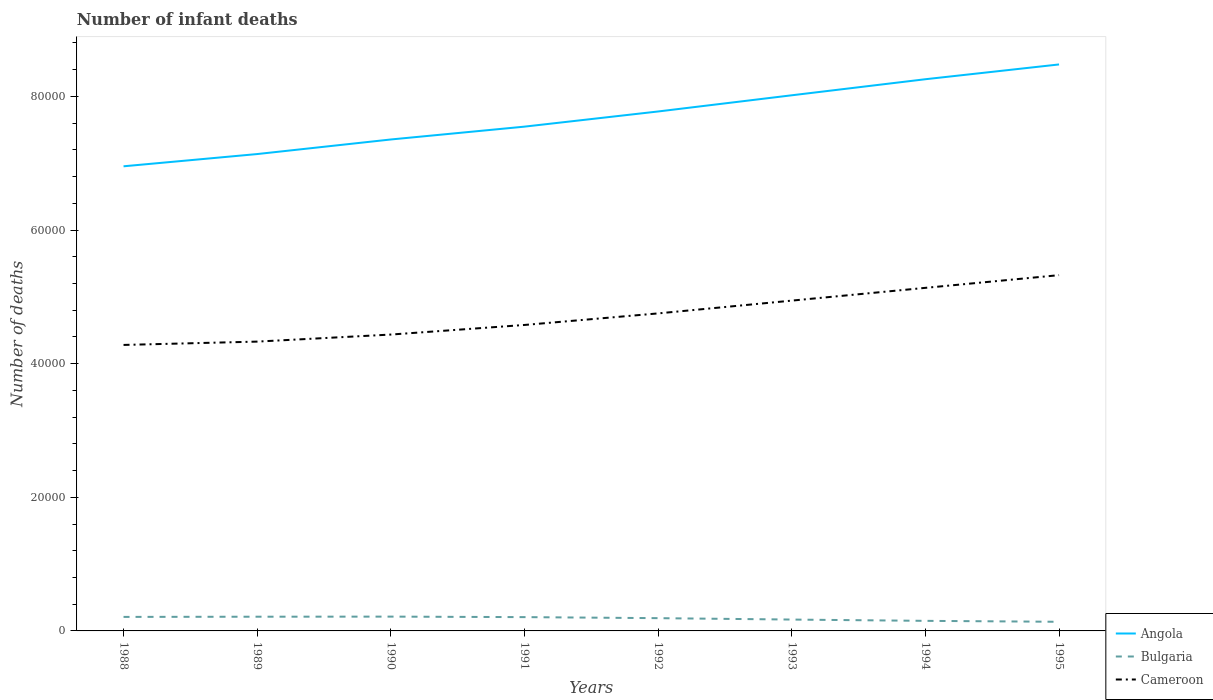Across all years, what is the maximum number of infant deaths in Bulgaria?
Offer a terse response. 1367. What is the total number of infant deaths in Bulgaria in the graph?
Ensure brevity in your answer.  427. What is the difference between the highest and the second highest number of infant deaths in Cameroon?
Make the answer very short. 1.04e+04. Is the number of infant deaths in Angola strictly greater than the number of infant deaths in Bulgaria over the years?
Your answer should be very brief. No. What is the difference between two consecutive major ticks on the Y-axis?
Provide a short and direct response. 2.00e+04. Are the values on the major ticks of Y-axis written in scientific E-notation?
Your answer should be compact. No. Where does the legend appear in the graph?
Your response must be concise. Bottom right. What is the title of the graph?
Give a very brief answer. Number of infant deaths. Does "Iran" appear as one of the legend labels in the graph?
Your response must be concise. No. What is the label or title of the X-axis?
Offer a very short reply. Years. What is the label or title of the Y-axis?
Your answer should be very brief. Number of deaths. What is the Number of deaths of Angola in 1988?
Your answer should be very brief. 6.95e+04. What is the Number of deaths of Bulgaria in 1988?
Make the answer very short. 2097. What is the Number of deaths in Cameroon in 1988?
Your answer should be very brief. 4.28e+04. What is the Number of deaths of Angola in 1989?
Offer a terse response. 7.14e+04. What is the Number of deaths of Bulgaria in 1989?
Your answer should be compact. 2127. What is the Number of deaths of Cameroon in 1989?
Provide a short and direct response. 4.33e+04. What is the Number of deaths in Angola in 1990?
Your response must be concise. 7.35e+04. What is the Number of deaths of Bulgaria in 1990?
Make the answer very short. 2141. What is the Number of deaths of Cameroon in 1990?
Offer a terse response. 4.44e+04. What is the Number of deaths in Angola in 1991?
Provide a short and direct response. 7.55e+04. What is the Number of deaths of Bulgaria in 1991?
Offer a very short reply. 2065. What is the Number of deaths in Cameroon in 1991?
Offer a terse response. 4.58e+04. What is the Number of deaths of Angola in 1992?
Your answer should be compact. 7.77e+04. What is the Number of deaths of Bulgaria in 1992?
Provide a succinct answer. 1910. What is the Number of deaths of Cameroon in 1992?
Offer a very short reply. 4.75e+04. What is the Number of deaths in Angola in 1993?
Your answer should be compact. 8.02e+04. What is the Number of deaths of Bulgaria in 1993?
Keep it short and to the point. 1700. What is the Number of deaths in Cameroon in 1993?
Your answer should be very brief. 4.94e+04. What is the Number of deaths of Angola in 1994?
Your answer should be compact. 8.26e+04. What is the Number of deaths in Bulgaria in 1994?
Provide a succinct answer. 1507. What is the Number of deaths in Cameroon in 1994?
Your response must be concise. 5.13e+04. What is the Number of deaths in Angola in 1995?
Your answer should be very brief. 8.48e+04. What is the Number of deaths of Bulgaria in 1995?
Make the answer very short. 1367. What is the Number of deaths of Cameroon in 1995?
Provide a short and direct response. 5.32e+04. Across all years, what is the maximum Number of deaths of Angola?
Ensure brevity in your answer.  8.48e+04. Across all years, what is the maximum Number of deaths in Bulgaria?
Provide a succinct answer. 2141. Across all years, what is the maximum Number of deaths of Cameroon?
Give a very brief answer. 5.32e+04. Across all years, what is the minimum Number of deaths in Angola?
Make the answer very short. 6.95e+04. Across all years, what is the minimum Number of deaths of Bulgaria?
Keep it short and to the point. 1367. Across all years, what is the minimum Number of deaths of Cameroon?
Provide a succinct answer. 4.28e+04. What is the total Number of deaths of Angola in the graph?
Provide a short and direct response. 6.15e+05. What is the total Number of deaths of Bulgaria in the graph?
Make the answer very short. 1.49e+04. What is the total Number of deaths of Cameroon in the graph?
Offer a very short reply. 3.78e+05. What is the difference between the Number of deaths of Angola in 1988 and that in 1989?
Offer a terse response. -1832. What is the difference between the Number of deaths of Cameroon in 1988 and that in 1989?
Your answer should be very brief. -498. What is the difference between the Number of deaths in Angola in 1988 and that in 1990?
Make the answer very short. -4014. What is the difference between the Number of deaths of Bulgaria in 1988 and that in 1990?
Provide a succinct answer. -44. What is the difference between the Number of deaths of Cameroon in 1988 and that in 1990?
Offer a terse response. -1553. What is the difference between the Number of deaths in Angola in 1988 and that in 1991?
Your answer should be compact. -5935. What is the difference between the Number of deaths of Bulgaria in 1988 and that in 1991?
Offer a terse response. 32. What is the difference between the Number of deaths in Cameroon in 1988 and that in 1991?
Your answer should be very brief. -2989. What is the difference between the Number of deaths of Angola in 1988 and that in 1992?
Make the answer very short. -8204. What is the difference between the Number of deaths in Bulgaria in 1988 and that in 1992?
Your response must be concise. 187. What is the difference between the Number of deaths of Cameroon in 1988 and that in 1992?
Your answer should be very brief. -4719. What is the difference between the Number of deaths of Angola in 1988 and that in 1993?
Your response must be concise. -1.06e+04. What is the difference between the Number of deaths in Bulgaria in 1988 and that in 1993?
Give a very brief answer. 397. What is the difference between the Number of deaths of Cameroon in 1988 and that in 1993?
Provide a succinct answer. -6631. What is the difference between the Number of deaths in Angola in 1988 and that in 1994?
Provide a short and direct response. -1.30e+04. What is the difference between the Number of deaths of Bulgaria in 1988 and that in 1994?
Your response must be concise. 590. What is the difference between the Number of deaths of Cameroon in 1988 and that in 1994?
Provide a short and direct response. -8543. What is the difference between the Number of deaths of Angola in 1988 and that in 1995?
Give a very brief answer. -1.52e+04. What is the difference between the Number of deaths in Bulgaria in 1988 and that in 1995?
Make the answer very short. 730. What is the difference between the Number of deaths in Cameroon in 1988 and that in 1995?
Your response must be concise. -1.04e+04. What is the difference between the Number of deaths in Angola in 1989 and that in 1990?
Offer a very short reply. -2182. What is the difference between the Number of deaths in Bulgaria in 1989 and that in 1990?
Make the answer very short. -14. What is the difference between the Number of deaths of Cameroon in 1989 and that in 1990?
Provide a short and direct response. -1055. What is the difference between the Number of deaths in Angola in 1989 and that in 1991?
Keep it short and to the point. -4103. What is the difference between the Number of deaths of Bulgaria in 1989 and that in 1991?
Give a very brief answer. 62. What is the difference between the Number of deaths of Cameroon in 1989 and that in 1991?
Keep it short and to the point. -2491. What is the difference between the Number of deaths in Angola in 1989 and that in 1992?
Your answer should be very brief. -6372. What is the difference between the Number of deaths in Bulgaria in 1989 and that in 1992?
Offer a terse response. 217. What is the difference between the Number of deaths in Cameroon in 1989 and that in 1992?
Provide a succinct answer. -4221. What is the difference between the Number of deaths in Angola in 1989 and that in 1993?
Your answer should be very brief. -8794. What is the difference between the Number of deaths in Bulgaria in 1989 and that in 1993?
Give a very brief answer. 427. What is the difference between the Number of deaths of Cameroon in 1989 and that in 1993?
Provide a short and direct response. -6133. What is the difference between the Number of deaths in Angola in 1989 and that in 1994?
Your response must be concise. -1.12e+04. What is the difference between the Number of deaths of Bulgaria in 1989 and that in 1994?
Provide a succinct answer. 620. What is the difference between the Number of deaths in Cameroon in 1989 and that in 1994?
Offer a terse response. -8045. What is the difference between the Number of deaths of Angola in 1989 and that in 1995?
Give a very brief answer. -1.34e+04. What is the difference between the Number of deaths of Bulgaria in 1989 and that in 1995?
Keep it short and to the point. 760. What is the difference between the Number of deaths of Cameroon in 1989 and that in 1995?
Ensure brevity in your answer.  -9946. What is the difference between the Number of deaths in Angola in 1990 and that in 1991?
Make the answer very short. -1921. What is the difference between the Number of deaths in Cameroon in 1990 and that in 1991?
Provide a succinct answer. -1436. What is the difference between the Number of deaths of Angola in 1990 and that in 1992?
Give a very brief answer. -4190. What is the difference between the Number of deaths of Bulgaria in 1990 and that in 1992?
Keep it short and to the point. 231. What is the difference between the Number of deaths in Cameroon in 1990 and that in 1992?
Provide a short and direct response. -3166. What is the difference between the Number of deaths of Angola in 1990 and that in 1993?
Offer a very short reply. -6612. What is the difference between the Number of deaths in Bulgaria in 1990 and that in 1993?
Give a very brief answer. 441. What is the difference between the Number of deaths in Cameroon in 1990 and that in 1993?
Give a very brief answer. -5078. What is the difference between the Number of deaths of Angola in 1990 and that in 1994?
Give a very brief answer. -9017. What is the difference between the Number of deaths of Bulgaria in 1990 and that in 1994?
Offer a very short reply. 634. What is the difference between the Number of deaths of Cameroon in 1990 and that in 1994?
Your response must be concise. -6990. What is the difference between the Number of deaths in Angola in 1990 and that in 1995?
Provide a succinct answer. -1.12e+04. What is the difference between the Number of deaths of Bulgaria in 1990 and that in 1995?
Ensure brevity in your answer.  774. What is the difference between the Number of deaths in Cameroon in 1990 and that in 1995?
Provide a succinct answer. -8891. What is the difference between the Number of deaths in Angola in 1991 and that in 1992?
Provide a short and direct response. -2269. What is the difference between the Number of deaths in Bulgaria in 1991 and that in 1992?
Your answer should be very brief. 155. What is the difference between the Number of deaths in Cameroon in 1991 and that in 1992?
Ensure brevity in your answer.  -1730. What is the difference between the Number of deaths in Angola in 1991 and that in 1993?
Your response must be concise. -4691. What is the difference between the Number of deaths of Bulgaria in 1991 and that in 1993?
Provide a succinct answer. 365. What is the difference between the Number of deaths of Cameroon in 1991 and that in 1993?
Ensure brevity in your answer.  -3642. What is the difference between the Number of deaths of Angola in 1991 and that in 1994?
Keep it short and to the point. -7096. What is the difference between the Number of deaths of Bulgaria in 1991 and that in 1994?
Make the answer very short. 558. What is the difference between the Number of deaths of Cameroon in 1991 and that in 1994?
Make the answer very short. -5554. What is the difference between the Number of deaths in Angola in 1991 and that in 1995?
Provide a succinct answer. -9308. What is the difference between the Number of deaths of Bulgaria in 1991 and that in 1995?
Your answer should be very brief. 698. What is the difference between the Number of deaths of Cameroon in 1991 and that in 1995?
Your response must be concise. -7455. What is the difference between the Number of deaths in Angola in 1992 and that in 1993?
Keep it short and to the point. -2422. What is the difference between the Number of deaths in Bulgaria in 1992 and that in 1993?
Your response must be concise. 210. What is the difference between the Number of deaths of Cameroon in 1992 and that in 1993?
Make the answer very short. -1912. What is the difference between the Number of deaths in Angola in 1992 and that in 1994?
Make the answer very short. -4827. What is the difference between the Number of deaths of Bulgaria in 1992 and that in 1994?
Make the answer very short. 403. What is the difference between the Number of deaths in Cameroon in 1992 and that in 1994?
Offer a terse response. -3824. What is the difference between the Number of deaths in Angola in 1992 and that in 1995?
Give a very brief answer. -7039. What is the difference between the Number of deaths of Bulgaria in 1992 and that in 1995?
Offer a terse response. 543. What is the difference between the Number of deaths in Cameroon in 1992 and that in 1995?
Keep it short and to the point. -5725. What is the difference between the Number of deaths in Angola in 1993 and that in 1994?
Offer a very short reply. -2405. What is the difference between the Number of deaths of Bulgaria in 1993 and that in 1994?
Provide a succinct answer. 193. What is the difference between the Number of deaths in Cameroon in 1993 and that in 1994?
Offer a very short reply. -1912. What is the difference between the Number of deaths in Angola in 1993 and that in 1995?
Make the answer very short. -4617. What is the difference between the Number of deaths of Bulgaria in 1993 and that in 1995?
Offer a very short reply. 333. What is the difference between the Number of deaths of Cameroon in 1993 and that in 1995?
Keep it short and to the point. -3813. What is the difference between the Number of deaths of Angola in 1994 and that in 1995?
Keep it short and to the point. -2212. What is the difference between the Number of deaths of Bulgaria in 1994 and that in 1995?
Keep it short and to the point. 140. What is the difference between the Number of deaths of Cameroon in 1994 and that in 1995?
Provide a succinct answer. -1901. What is the difference between the Number of deaths of Angola in 1988 and the Number of deaths of Bulgaria in 1989?
Your answer should be very brief. 6.74e+04. What is the difference between the Number of deaths of Angola in 1988 and the Number of deaths of Cameroon in 1989?
Give a very brief answer. 2.62e+04. What is the difference between the Number of deaths of Bulgaria in 1988 and the Number of deaths of Cameroon in 1989?
Keep it short and to the point. -4.12e+04. What is the difference between the Number of deaths in Angola in 1988 and the Number of deaths in Bulgaria in 1990?
Your answer should be very brief. 6.74e+04. What is the difference between the Number of deaths of Angola in 1988 and the Number of deaths of Cameroon in 1990?
Provide a succinct answer. 2.52e+04. What is the difference between the Number of deaths of Bulgaria in 1988 and the Number of deaths of Cameroon in 1990?
Your answer should be very brief. -4.23e+04. What is the difference between the Number of deaths of Angola in 1988 and the Number of deaths of Bulgaria in 1991?
Provide a short and direct response. 6.75e+04. What is the difference between the Number of deaths in Angola in 1988 and the Number of deaths in Cameroon in 1991?
Your answer should be compact. 2.37e+04. What is the difference between the Number of deaths of Bulgaria in 1988 and the Number of deaths of Cameroon in 1991?
Offer a very short reply. -4.37e+04. What is the difference between the Number of deaths in Angola in 1988 and the Number of deaths in Bulgaria in 1992?
Provide a succinct answer. 6.76e+04. What is the difference between the Number of deaths in Angola in 1988 and the Number of deaths in Cameroon in 1992?
Your response must be concise. 2.20e+04. What is the difference between the Number of deaths in Bulgaria in 1988 and the Number of deaths in Cameroon in 1992?
Ensure brevity in your answer.  -4.54e+04. What is the difference between the Number of deaths in Angola in 1988 and the Number of deaths in Bulgaria in 1993?
Your response must be concise. 6.78e+04. What is the difference between the Number of deaths of Angola in 1988 and the Number of deaths of Cameroon in 1993?
Your answer should be very brief. 2.01e+04. What is the difference between the Number of deaths of Bulgaria in 1988 and the Number of deaths of Cameroon in 1993?
Provide a succinct answer. -4.73e+04. What is the difference between the Number of deaths in Angola in 1988 and the Number of deaths in Bulgaria in 1994?
Give a very brief answer. 6.80e+04. What is the difference between the Number of deaths of Angola in 1988 and the Number of deaths of Cameroon in 1994?
Provide a short and direct response. 1.82e+04. What is the difference between the Number of deaths in Bulgaria in 1988 and the Number of deaths in Cameroon in 1994?
Give a very brief answer. -4.92e+04. What is the difference between the Number of deaths of Angola in 1988 and the Number of deaths of Bulgaria in 1995?
Your answer should be very brief. 6.82e+04. What is the difference between the Number of deaths in Angola in 1988 and the Number of deaths in Cameroon in 1995?
Provide a succinct answer. 1.63e+04. What is the difference between the Number of deaths in Bulgaria in 1988 and the Number of deaths in Cameroon in 1995?
Provide a succinct answer. -5.11e+04. What is the difference between the Number of deaths of Angola in 1989 and the Number of deaths of Bulgaria in 1990?
Provide a succinct answer. 6.92e+04. What is the difference between the Number of deaths in Angola in 1989 and the Number of deaths in Cameroon in 1990?
Keep it short and to the point. 2.70e+04. What is the difference between the Number of deaths of Bulgaria in 1989 and the Number of deaths of Cameroon in 1990?
Ensure brevity in your answer.  -4.22e+04. What is the difference between the Number of deaths of Angola in 1989 and the Number of deaths of Bulgaria in 1991?
Your answer should be compact. 6.93e+04. What is the difference between the Number of deaths of Angola in 1989 and the Number of deaths of Cameroon in 1991?
Your answer should be very brief. 2.56e+04. What is the difference between the Number of deaths of Bulgaria in 1989 and the Number of deaths of Cameroon in 1991?
Make the answer very short. -4.37e+04. What is the difference between the Number of deaths in Angola in 1989 and the Number of deaths in Bulgaria in 1992?
Offer a very short reply. 6.95e+04. What is the difference between the Number of deaths in Angola in 1989 and the Number of deaths in Cameroon in 1992?
Your answer should be very brief. 2.38e+04. What is the difference between the Number of deaths in Bulgaria in 1989 and the Number of deaths in Cameroon in 1992?
Ensure brevity in your answer.  -4.54e+04. What is the difference between the Number of deaths in Angola in 1989 and the Number of deaths in Bulgaria in 1993?
Provide a succinct answer. 6.97e+04. What is the difference between the Number of deaths in Angola in 1989 and the Number of deaths in Cameroon in 1993?
Ensure brevity in your answer.  2.19e+04. What is the difference between the Number of deaths of Bulgaria in 1989 and the Number of deaths of Cameroon in 1993?
Offer a very short reply. -4.73e+04. What is the difference between the Number of deaths in Angola in 1989 and the Number of deaths in Bulgaria in 1994?
Your answer should be very brief. 6.99e+04. What is the difference between the Number of deaths in Angola in 1989 and the Number of deaths in Cameroon in 1994?
Keep it short and to the point. 2.00e+04. What is the difference between the Number of deaths in Bulgaria in 1989 and the Number of deaths in Cameroon in 1994?
Provide a succinct answer. -4.92e+04. What is the difference between the Number of deaths in Angola in 1989 and the Number of deaths in Bulgaria in 1995?
Offer a terse response. 7.00e+04. What is the difference between the Number of deaths of Angola in 1989 and the Number of deaths of Cameroon in 1995?
Offer a very short reply. 1.81e+04. What is the difference between the Number of deaths in Bulgaria in 1989 and the Number of deaths in Cameroon in 1995?
Offer a very short reply. -5.11e+04. What is the difference between the Number of deaths in Angola in 1990 and the Number of deaths in Bulgaria in 1991?
Provide a short and direct response. 7.15e+04. What is the difference between the Number of deaths in Angola in 1990 and the Number of deaths in Cameroon in 1991?
Provide a short and direct response. 2.78e+04. What is the difference between the Number of deaths in Bulgaria in 1990 and the Number of deaths in Cameroon in 1991?
Provide a succinct answer. -4.36e+04. What is the difference between the Number of deaths in Angola in 1990 and the Number of deaths in Bulgaria in 1992?
Provide a succinct answer. 7.16e+04. What is the difference between the Number of deaths of Angola in 1990 and the Number of deaths of Cameroon in 1992?
Your response must be concise. 2.60e+04. What is the difference between the Number of deaths of Bulgaria in 1990 and the Number of deaths of Cameroon in 1992?
Your answer should be compact. -4.54e+04. What is the difference between the Number of deaths of Angola in 1990 and the Number of deaths of Bulgaria in 1993?
Ensure brevity in your answer.  7.18e+04. What is the difference between the Number of deaths of Angola in 1990 and the Number of deaths of Cameroon in 1993?
Your answer should be compact. 2.41e+04. What is the difference between the Number of deaths in Bulgaria in 1990 and the Number of deaths in Cameroon in 1993?
Make the answer very short. -4.73e+04. What is the difference between the Number of deaths in Angola in 1990 and the Number of deaths in Bulgaria in 1994?
Your answer should be very brief. 7.20e+04. What is the difference between the Number of deaths of Angola in 1990 and the Number of deaths of Cameroon in 1994?
Provide a short and direct response. 2.22e+04. What is the difference between the Number of deaths of Bulgaria in 1990 and the Number of deaths of Cameroon in 1994?
Your response must be concise. -4.92e+04. What is the difference between the Number of deaths in Angola in 1990 and the Number of deaths in Bulgaria in 1995?
Offer a very short reply. 7.22e+04. What is the difference between the Number of deaths in Angola in 1990 and the Number of deaths in Cameroon in 1995?
Provide a succinct answer. 2.03e+04. What is the difference between the Number of deaths of Bulgaria in 1990 and the Number of deaths of Cameroon in 1995?
Your answer should be very brief. -5.11e+04. What is the difference between the Number of deaths of Angola in 1991 and the Number of deaths of Bulgaria in 1992?
Your response must be concise. 7.36e+04. What is the difference between the Number of deaths of Angola in 1991 and the Number of deaths of Cameroon in 1992?
Make the answer very short. 2.80e+04. What is the difference between the Number of deaths of Bulgaria in 1991 and the Number of deaths of Cameroon in 1992?
Provide a short and direct response. -4.55e+04. What is the difference between the Number of deaths of Angola in 1991 and the Number of deaths of Bulgaria in 1993?
Provide a succinct answer. 7.38e+04. What is the difference between the Number of deaths of Angola in 1991 and the Number of deaths of Cameroon in 1993?
Make the answer very short. 2.60e+04. What is the difference between the Number of deaths of Bulgaria in 1991 and the Number of deaths of Cameroon in 1993?
Your answer should be very brief. -4.74e+04. What is the difference between the Number of deaths of Angola in 1991 and the Number of deaths of Bulgaria in 1994?
Offer a terse response. 7.40e+04. What is the difference between the Number of deaths of Angola in 1991 and the Number of deaths of Cameroon in 1994?
Offer a very short reply. 2.41e+04. What is the difference between the Number of deaths in Bulgaria in 1991 and the Number of deaths in Cameroon in 1994?
Ensure brevity in your answer.  -4.93e+04. What is the difference between the Number of deaths of Angola in 1991 and the Number of deaths of Bulgaria in 1995?
Your answer should be very brief. 7.41e+04. What is the difference between the Number of deaths of Angola in 1991 and the Number of deaths of Cameroon in 1995?
Provide a succinct answer. 2.22e+04. What is the difference between the Number of deaths of Bulgaria in 1991 and the Number of deaths of Cameroon in 1995?
Give a very brief answer. -5.12e+04. What is the difference between the Number of deaths in Angola in 1992 and the Number of deaths in Bulgaria in 1993?
Your answer should be compact. 7.60e+04. What is the difference between the Number of deaths of Angola in 1992 and the Number of deaths of Cameroon in 1993?
Your response must be concise. 2.83e+04. What is the difference between the Number of deaths in Bulgaria in 1992 and the Number of deaths in Cameroon in 1993?
Make the answer very short. -4.75e+04. What is the difference between the Number of deaths in Angola in 1992 and the Number of deaths in Bulgaria in 1994?
Your response must be concise. 7.62e+04. What is the difference between the Number of deaths in Angola in 1992 and the Number of deaths in Cameroon in 1994?
Offer a terse response. 2.64e+04. What is the difference between the Number of deaths in Bulgaria in 1992 and the Number of deaths in Cameroon in 1994?
Ensure brevity in your answer.  -4.94e+04. What is the difference between the Number of deaths in Angola in 1992 and the Number of deaths in Bulgaria in 1995?
Keep it short and to the point. 7.64e+04. What is the difference between the Number of deaths in Angola in 1992 and the Number of deaths in Cameroon in 1995?
Provide a short and direct response. 2.45e+04. What is the difference between the Number of deaths in Bulgaria in 1992 and the Number of deaths in Cameroon in 1995?
Your response must be concise. -5.13e+04. What is the difference between the Number of deaths of Angola in 1993 and the Number of deaths of Bulgaria in 1994?
Offer a very short reply. 7.87e+04. What is the difference between the Number of deaths in Angola in 1993 and the Number of deaths in Cameroon in 1994?
Ensure brevity in your answer.  2.88e+04. What is the difference between the Number of deaths of Bulgaria in 1993 and the Number of deaths of Cameroon in 1994?
Provide a succinct answer. -4.96e+04. What is the difference between the Number of deaths of Angola in 1993 and the Number of deaths of Bulgaria in 1995?
Provide a succinct answer. 7.88e+04. What is the difference between the Number of deaths in Angola in 1993 and the Number of deaths in Cameroon in 1995?
Keep it short and to the point. 2.69e+04. What is the difference between the Number of deaths of Bulgaria in 1993 and the Number of deaths of Cameroon in 1995?
Provide a succinct answer. -5.15e+04. What is the difference between the Number of deaths in Angola in 1994 and the Number of deaths in Bulgaria in 1995?
Your response must be concise. 8.12e+04. What is the difference between the Number of deaths of Angola in 1994 and the Number of deaths of Cameroon in 1995?
Provide a succinct answer. 2.93e+04. What is the difference between the Number of deaths in Bulgaria in 1994 and the Number of deaths in Cameroon in 1995?
Keep it short and to the point. -5.17e+04. What is the average Number of deaths of Angola per year?
Provide a succinct answer. 7.69e+04. What is the average Number of deaths in Bulgaria per year?
Give a very brief answer. 1864.25. What is the average Number of deaths in Cameroon per year?
Make the answer very short. 4.72e+04. In the year 1988, what is the difference between the Number of deaths in Angola and Number of deaths in Bulgaria?
Make the answer very short. 6.74e+04. In the year 1988, what is the difference between the Number of deaths of Angola and Number of deaths of Cameroon?
Make the answer very short. 2.67e+04. In the year 1988, what is the difference between the Number of deaths of Bulgaria and Number of deaths of Cameroon?
Provide a short and direct response. -4.07e+04. In the year 1989, what is the difference between the Number of deaths of Angola and Number of deaths of Bulgaria?
Ensure brevity in your answer.  6.92e+04. In the year 1989, what is the difference between the Number of deaths in Angola and Number of deaths in Cameroon?
Your response must be concise. 2.81e+04. In the year 1989, what is the difference between the Number of deaths of Bulgaria and Number of deaths of Cameroon?
Your response must be concise. -4.12e+04. In the year 1990, what is the difference between the Number of deaths of Angola and Number of deaths of Bulgaria?
Your answer should be very brief. 7.14e+04. In the year 1990, what is the difference between the Number of deaths of Angola and Number of deaths of Cameroon?
Your answer should be very brief. 2.92e+04. In the year 1990, what is the difference between the Number of deaths of Bulgaria and Number of deaths of Cameroon?
Offer a very short reply. -4.22e+04. In the year 1991, what is the difference between the Number of deaths in Angola and Number of deaths in Bulgaria?
Offer a terse response. 7.34e+04. In the year 1991, what is the difference between the Number of deaths of Angola and Number of deaths of Cameroon?
Offer a terse response. 2.97e+04. In the year 1991, what is the difference between the Number of deaths of Bulgaria and Number of deaths of Cameroon?
Ensure brevity in your answer.  -4.37e+04. In the year 1992, what is the difference between the Number of deaths of Angola and Number of deaths of Bulgaria?
Your answer should be very brief. 7.58e+04. In the year 1992, what is the difference between the Number of deaths in Angola and Number of deaths in Cameroon?
Keep it short and to the point. 3.02e+04. In the year 1992, what is the difference between the Number of deaths in Bulgaria and Number of deaths in Cameroon?
Provide a succinct answer. -4.56e+04. In the year 1993, what is the difference between the Number of deaths of Angola and Number of deaths of Bulgaria?
Your answer should be compact. 7.85e+04. In the year 1993, what is the difference between the Number of deaths of Angola and Number of deaths of Cameroon?
Your response must be concise. 3.07e+04. In the year 1993, what is the difference between the Number of deaths of Bulgaria and Number of deaths of Cameroon?
Your answer should be very brief. -4.77e+04. In the year 1994, what is the difference between the Number of deaths in Angola and Number of deaths in Bulgaria?
Give a very brief answer. 8.11e+04. In the year 1994, what is the difference between the Number of deaths of Angola and Number of deaths of Cameroon?
Your answer should be compact. 3.12e+04. In the year 1994, what is the difference between the Number of deaths in Bulgaria and Number of deaths in Cameroon?
Keep it short and to the point. -4.98e+04. In the year 1995, what is the difference between the Number of deaths in Angola and Number of deaths in Bulgaria?
Give a very brief answer. 8.34e+04. In the year 1995, what is the difference between the Number of deaths of Angola and Number of deaths of Cameroon?
Ensure brevity in your answer.  3.15e+04. In the year 1995, what is the difference between the Number of deaths in Bulgaria and Number of deaths in Cameroon?
Your response must be concise. -5.19e+04. What is the ratio of the Number of deaths in Angola in 1988 to that in 1989?
Make the answer very short. 0.97. What is the ratio of the Number of deaths in Bulgaria in 1988 to that in 1989?
Offer a very short reply. 0.99. What is the ratio of the Number of deaths in Cameroon in 1988 to that in 1989?
Offer a terse response. 0.99. What is the ratio of the Number of deaths in Angola in 1988 to that in 1990?
Your answer should be compact. 0.95. What is the ratio of the Number of deaths in Bulgaria in 1988 to that in 1990?
Your response must be concise. 0.98. What is the ratio of the Number of deaths of Angola in 1988 to that in 1991?
Your response must be concise. 0.92. What is the ratio of the Number of deaths in Bulgaria in 1988 to that in 1991?
Your answer should be very brief. 1.02. What is the ratio of the Number of deaths of Cameroon in 1988 to that in 1991?
Offer a very short reply. 0.93. What is the ratio of the Number of deaths of Angola in 1988 to that in 1992?
Your response must be concise. 0.89. What is the ratio of the Number of deaths of Bulgaria in 1988 to that in 1992?
Your answer should be very brief. 1.1. What is the ratio of the Number of deaths of Cameroon in 1988 to that in 1992?
Offer a terse response. 0.9. What is the ratio of the Number of deaths of Angola in 1988 to that in 1993?
Make the answer very short. 0.87. What is the ratio of the Number of deaths of Bulgaria in 1988 to that in 1993?
Ensure brevity in your answer.  1.23. What is the ratio of the Number of deaths in Cameroon in 1988 to that in 1993?
Make the answer very short. 0.87. What is the ratio of the Number of deaths in Angola in 1988 to that in 1994?
Offer a very short reply. 0.84. What is the ratio of the Number of deaths of Bulgaria in 1988 to that in 1994?
Give a very brief answer. 1.39. What is the ratio of the Number of deaths of Cameroon in 1988 to that in 1994?
Ensure brevity in your answer.  0.83. What is the ratio of the Number of deaths in Angola in 1988 to that in 1995?
Keep it short and to the point. 0.82. What is the ratio of the Number of deaths of Bulgaria in 1988 to that in 1995?
Your answer should be compact. 1.53. What is the ratio of the Number of deaths of Cameroon in 1988 to that in 1995?
Make the answer very short. 0.8. What is the ratio of the Number of deaths in Angola in 1989 to that in 1990?
Ensure brevity in your answer.  0.97. What is the ratio of the Number of deaths in Cameroon in 1989 to that in 1990?
Ensure brevity in your answer.  0.98. What is the ratio of the Number of deaths in Angola in 1989 to that in 1991?
Provide a short and direct response. 0.95. What is the ratio of the Number of deaths of Cameroon in 1989 to that in 1991?
Make the answer very short. 0.95. What is the ratio of the Number of deaths in Angola in 1989 to that in 1992?
Offer a very short reply. 0.92. What is the ratio of the Number of deaths in Bulgaria in 1989 to that in 1992?
Keep it short and to the point. 1.11. What is the ratio of the Number of deaths of Cameroon in 1989 to that in 1992?
Give a very brief answer. 0.91. What is the ratio of the Number of deaths of Angola in 1989 to that in 1993?
Keep it short and to the point. 0.89. What is the ratio of the Number of deaths in Bulgaria in 1989 to that in 1993?
Provide a succinct answer. 1.25. What is the ratio of the Number of deaths of Cameroon in 1989 to that in 1993?
Your response must be concise. 0.88. What is the ratio of the Number of deaths of Angola in 1989 to that in 1994?
Offer a terse response. 0.86. What is the ratio of the Number of deaths of Bulgaria in 1989 to that in 1994?
Offer a very short reply. 1.41. What is the ratio of the Number of deaths of Cameroon in 1989 to that in 1994?
Offer a terse response. 0.84. What is the ratio of the Number of deaths in Angola in 1989 to that in 1995?
Your response must be concise. 0.84. What is the ratio of the Number of deaths in Bulgaria in 1989 to that in 1995?
Offer a terse response. 1.56. What is the ratio of the Number of deaths of Cameroon in 1989 to that in 1995?
Provide a succinct answer. 0.81. What is the ratio of the Number of deaths in Angola in 1990 to that in 1991?
Provide a short and direct response. 0.97. What is the ratio of the Number of deaths of Bulgaria in 1990 to that in 1991?
Offer a very short reply. 1.04. What is the ratio of the Number of deaths of Cameroon in 1990 to that in 1991?
Provide a short and direct response. 0.97. What is the ratio of the Number of deaths in Angola in 1990 to that in 1992?
Make the answer very short. 0.95. What is the ratio of the Number of deaths of Bulgaria in 1990 to that in 1992?
Make the answer very short. 1.12. What is the ratio of the Number of deaths in Cameroon in 1990 to that in 1992?
Your response must be concise. 0.93. What is the ratio of the Number of deaths in Angola in 1990 to that in 1993?
Provide a succinct answer. 0.92. What is the ratio of the Number of deaths of Bulgaria in 1990 to that in 1993?
Keep it short and to the point. 1.26. What is the ratio of the Number of deaths in Cameroon in 1990 to that in 1993?
Offer a very short reply. 0.9. What is the ratio of the Number of deaths in Angola in 1990 to that in 1994?
Provide a succinct answer. 0.89. What is the ratio of the Number of deaths in Bulgaria in 1990 to that in 1994?
Offer a very short reply. 1.42. What is the ratio of the Number of deaths in Cameroon in 1990 to that in 1994?
Give a very brief answer. 0.86. What is the ratio of the Number of deaths of Angola in 1990 to that in 1995?
Give a very brief answer. 0.87. What is the ratio of the Number of deaths in Bulgaria in 1990 to that in 1995?
Ensure brevity in your answer.  1.57. What is the ratio of the Number of deaths in Cameroon in 1990 to that in 1995?
Ensure brevity in your answer.  0.83. What is the ratio of the Number of deaths of Angola in 1991 to that in 1992?
Keep it short and to the point. 0.97. What is the ratio of the Number of deaths in Bulgaria in 1991 to that in 1992?
Your response must be concise. 1.08. What is the ratio of the Number of deaths of Cameroon in 1991 to that in 1992?
Offer a very short reply. 0.96. What is the ratio of the Number of deaths in Angola in 1991 to that in 1993?
Make the answer very short. 0.94. What is the ratio of the Number of deaths in Bulgaria in 1991 to that in 1993?
Your answer should be very brief. 1.21. What is the ratio of the Number of deaths in Cameroon in 1991 to that in 1993?
Offer a terse response. 0.93. What is the ratio of the Number of deaths of Angola in 1991 to that in 1994?
Your answer should be compact. 0.91. What is the ratio of the Number of deaths in Bulgaria in 1991 to that in 1994?
Provide a succinct answer. 1.37. What is the ratio of the Number of deaths of Cameroon in 1991 to that in 1994?
Provide a short and direct response. 0.89. What is the ratio of the Number of deaths in Angola in 1991 to that in 1995?
Offer a very short reply. 0.89. What is the ratio of the Number of deaths of Bulgaria in 1991 to that in 1995?
Ensure brevity in your answer.  1.51. What is the ratio of the Number of deaths in Cameroon in 1991 to that in 1995?
Offer a very short reply. 0.86. What is the ratio of the Number of deaths in Angola in 1992 to that in 1993?
Provide a short and direct response. 0.97. What is the ratio of the Number of deaths in Bulgaria in 1992 to that in 1993?
Your answer should be very brief. 1.12. What is the ratio of the Number of deaths of Cameroon in 1992 to that in 1993?
Make the answer very short. 0.96. What is the ratio of the Number of deaths of Angola in 1992 to that in 1994?
Make the answer very short. 0.94. What is the ratio of the Number of deaths in Bulgaria in 1992 to that in 1994?
Offer a very short reply. 1.27. What is the ratio of the Number of deaths in Cameroon in 1992 to that in 1994?
Your answer should be compact. 0.93. What is the ratio of the Number of deaths in Angola in 1992 to that in 1995?
Provide a short and direct response. 0.92. What is the ratio of the Number of deaths of Bulgaria in 1992 to that in 1995?
Offer a very short reply. 1.4. What is the ratio of the Number of deaths of Cameroon in 1992 to that in 1995?
Give a very brief answer. 0.89. What is the ratio of the Number of deaths of Angola in 1993 to that in 1994?
Your answer should be very brief. 0.97. What is the ratio of the Number of deaths in Bulgaria in 1993 to that in 1994?
Give a very brief answer. 1.13. What is the ratio of the Number of deaths of Cameroon in 1993 to that in 1994?
Make the answer very short. 0.96. What is the ratio of the Number of deaths in Angola in 1993 to that in 1995?
Provide a succinct answer. 0.95. What is the ratio of the Number of deaths of Bulgaria in 1993 to that in 1995?
Offer a very short reply. 1.24. What is the ratio of the Number of deaths in Cameroon in 1993 to that in 1995?
Keep it short and to the point. 0.93. What is the ratio of the Number of deaths in Angola in 1994 to that in 1995?
Your answer should be compact. 0.97. What is the ratio of the Number of deaths in Bulgaria in 1994 to that in 1995?
Your answer should be very brief. 1.1. What is the ratio of the Number of deaths in Cameroon in 1994 to that in 1995?
Keep it short and to the point. 0.96. What is the difference between the highest and the second highest Number of deaths of Angola?
Make the answer very short. 2212. What is the difference between the highest and the second highest Number of deaths in Bulgaria?
Offer a terse response. 14. What is the difference between the highest and the second highest Number of deaths of Cameroon?
Give a very brief answer. 1901. What is the difference between the highest and the lowest Number of deaths of Angola?
Provide a short and direct response. 1.52e+04. What is the difference between the highest and the lowest Number of deaths in Bulgaria?
Provide a succinct answer. 774. What is the difference between the highest and the lowest Number of deaths of Cameroon?
Your answer should be compact. 1.04e+04. 